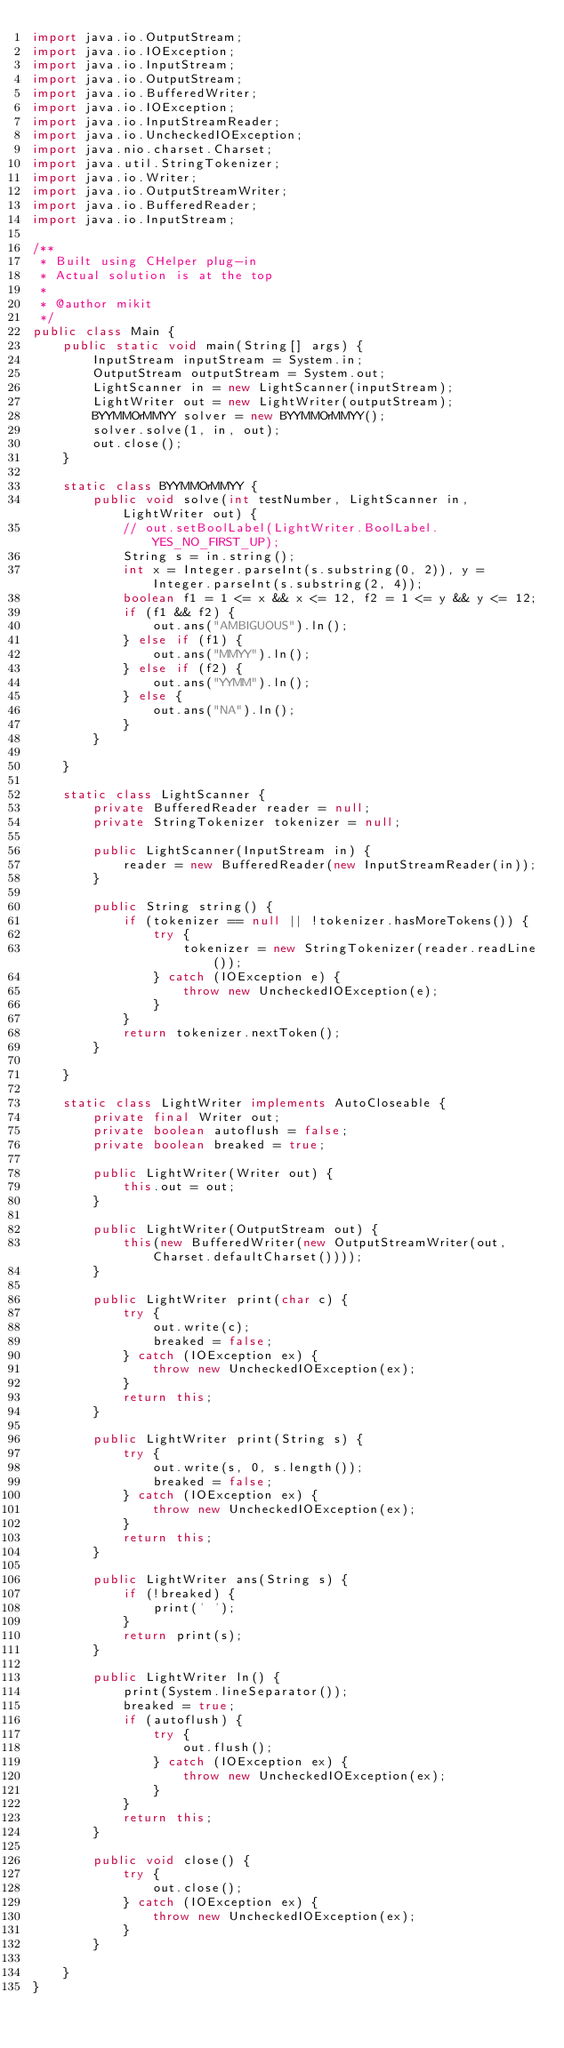<code> <loc_0><loc_0><loc_500><loc_500><_Java_>import java.io.OutputStream;
import java.io.IOException;
import java.io.InputStream;
import java.io.OutputStream;
import java.io.BufferedWriter;
import java.io.IOException;
import java.io.InputStreamReader;
import java.io.UncheckedIOException;
import java.nio.charset.Charset;
import java.util.StringTokenizer;
import java.io.Writer;
import java.io.OutputStreamWriter;
import java.io.BufferedReader;
import java.io.InputStream;

/**
 * Built using CHelper plug-in
 * Actual solution is at the top
 *
 * @author mikit
 */
public class Main {
    public static void main(String[] args) {
        InputStream inputStream = System.in;
        OutputStream outputStream = System.out;
        LightScanner in = new LightScanner(inputStream);
        LightWriter out = new LightWriter(outputStream);
        BYYMMOrMMYY solver = new BYYMMOrMMYY();
        solver.solve(1, in, out);
        out.close();
    }

    static class BYYMMOrMMYY {
        public void solve(int testNumber, LightScanner in, LightWriter out) {
            // out.setBoolLabel(LightWriter.BoolLabel.YES_NO_FIRST_UP);
            String s = in.string();
            int x = Integer.parseInt(s.substring(0, 2)), y = Integer.parseInt(s.substring(2, 4));
            boolean f1 = 1 <= x && x <= 12, f2 = 1 <= y && y <= 12;
            if (f1 && f2) {
                out.ans("AMBIGUOUS").ln();
            } else if (f1) {
                out.ans("MMYY").ln();
            } else if (f2) {
                out.ans("YYMM").ln();
            } else {
                out.ans("NA").ln();
            }
        }

    }

    static class LightScanner {
        private BufferedReader reader = null;
        private StringTokenizer tokenizer = null;

        public LightScanner(InputStream in) {
            reader = new BufferedReader(new InputStreamReader(in));
        }

        public String string() {
            if (tokenizer == null || !tokenizer.hasMoreTokens()) {
                try {
                    tokenizer = new StringTokenizer(reader.readLine());
                } catch (IOException e) {
                    throw new UncheckedIOException(e);
                }
            }
            return tokenizer.nextToken();
        }

    }

    static class LightWriter implements AutoCloseable {
        private final Writer out;
        private boolean autoflush = false;
        private boolean breaked = true;

        public LightWriter(Writer out) {
            this.out = out;
        }

        public LightWriter(OutputStream out) {
            this(new BufferedWriter(new OutputStreamWriter(out, Charset.defaultCharset())));
        }

        public LightWriter print(char c) {
            try {
                out.write(c);
                breaked = false;
            } catch (IOException ex) {
                throw new UncheckedIOException(ex);
            }
            return this;
        }

        public LightWriter print(String s) {
            try {
                out.write(s, 0, s.length());
                breaked = false;
            } catch (IOException ex) {
                throw new UncheckedIOException(ex);
            }
            return this;
        }

        public LightWriter ans(String s) {
            if (!breaked) {
                print(' ');
            }
            return print(s);
        }

        public LightWriter ln() {
            print(System.lineSeparator());
            breaked = true;
            if (autoflush) {
                try {
                    out.flush();
                } catch (IOException ex) {
                    throw new UncheckedIOException(ex);
                }
            }
            return this;
        }

        public void close() {
            try {
                out.close();
            } catch (IOException ex) {
                throw new UncheckedIOException(ex);
            }
        }

    }
}

</code> 